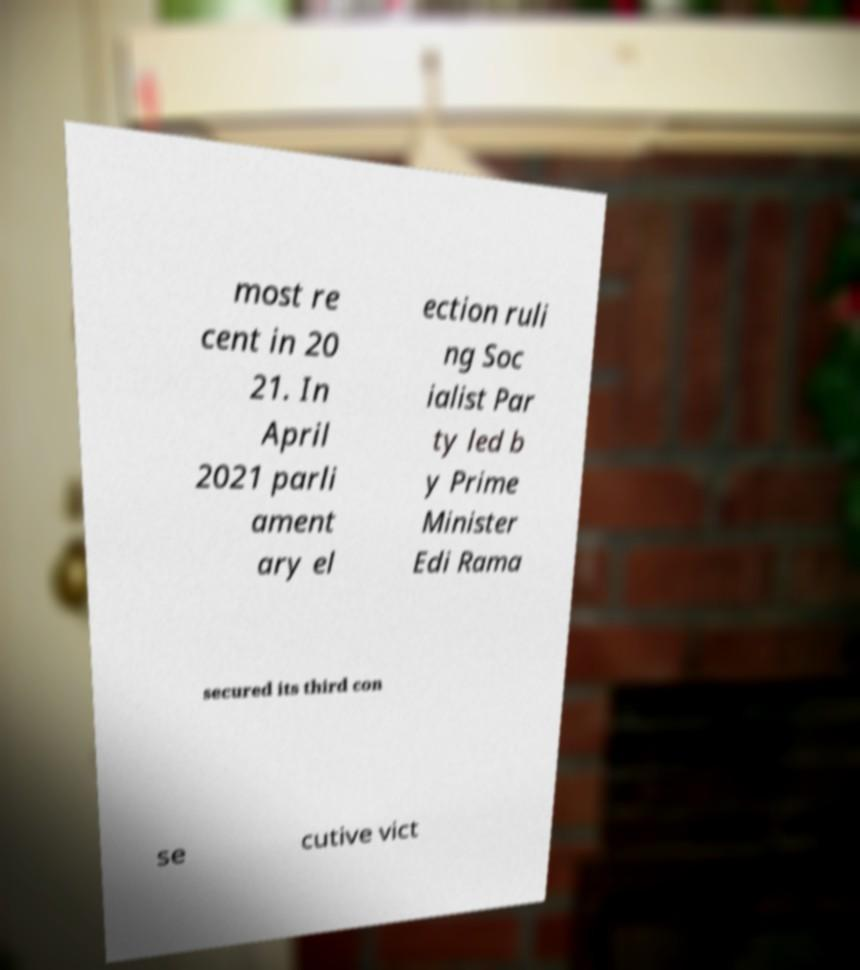I need the written content from this picture converted into text. Can you do that? most re cent in 20 21. In April 2021 parli ament ary el ection ruli ng Soc ialist Par ty led b y Prime Minister Edi Rama secured its third con se cutive vict 